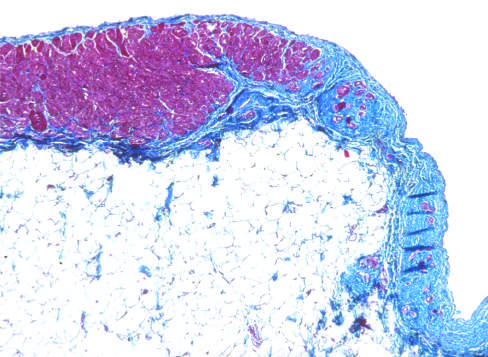does the congested portion of the ileum stain?
Answer the question using a single word or phrase. No 